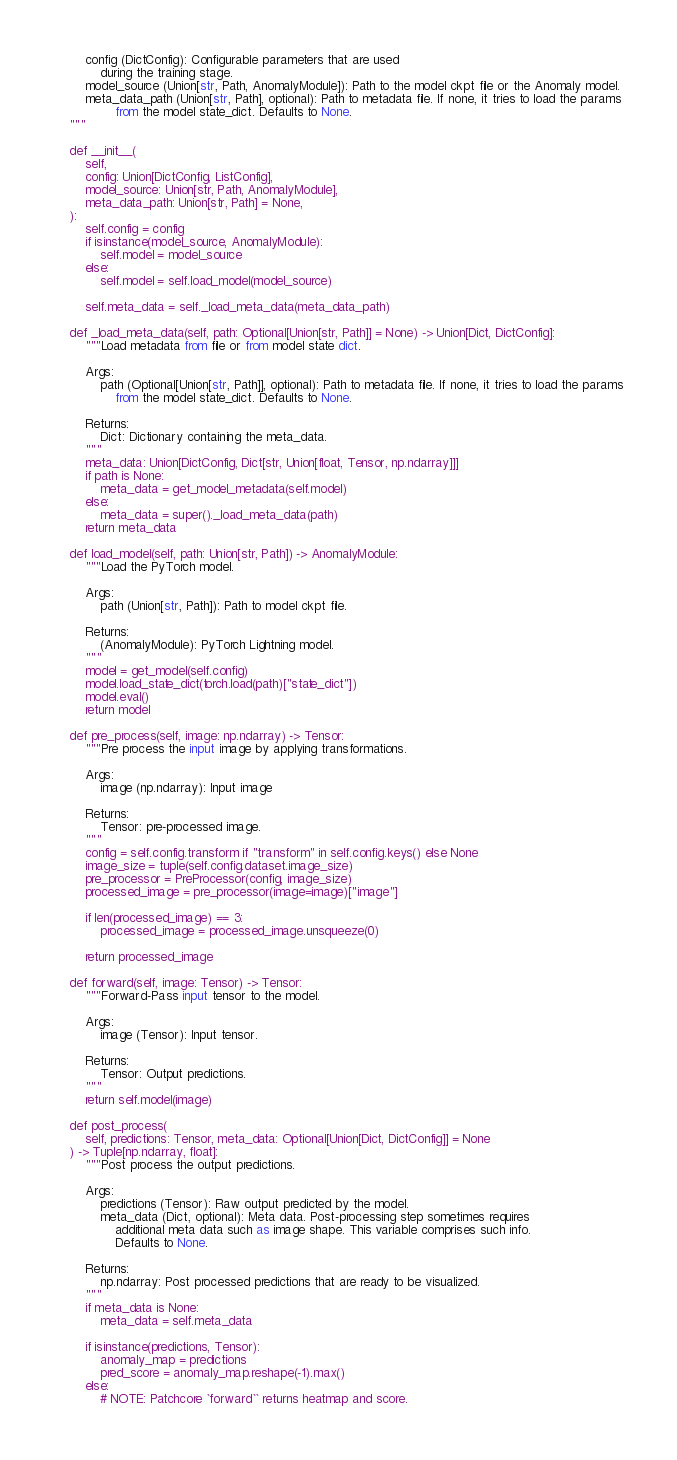Convert code to text. <code><loc_0><loc_0><loc_500><loc_500><_Python_>        config (DictConfig): Configurable parameters that are used
            during the training stage.
        model_source (Union[str, Path, AnomalyModule]): Path to the model ckpt file or the Anomaly model.
        meta_data_path (Union[str, Path], optional): Path to metadata file. If none, it tries to load the params
                from the model state_dict. Defaults to None.
    """

    def __init__(
        self,
        config: Union[DictConfig, ListConfig],
        model_source: Union[str, Path, AnomalyModule],
        meta_data_path: Union[str, Path] = None,
    ):
        self.config = config
        if isinstance(model_source, AnomalyModule):
            self.model = model_source
        else:
            self.model = self.load_model(model_source)

        self.meta_data = self._load_meta_data(meta_data_path)

    def _load_meta_data(self, path: Optional[Union[str, Path]] = None) -> Union[Dict, DictConfig]:
        """Load metadata from file or from model state dict.

        Args:
            path (Optional[Union[str, Path]], optional): Path to metadata file. If none, it tries to load the params
                from the model state_dict. Defaults to None.

        Returns:
            Dict: Dictionary containing the meta_data.
        """
        meta_data: Union[DictConfig, Dict[str, Union[float, Tensor, np.ndarray]]]
        if path is None:
            meta_data = get_model_metadata(self.model)
        else:
            meta_data = super()._load_meta_data(path)
        return meta_data

    def load_model(self, path: Union[str, Path]) -> AnomalyModule:
        """Load the PyTorch model.

        Args:
            path (Union[str, Path]): Path to model ckpt file.

        Returns:
            (AnomalyModule): PyTorch Lightning model.
        """
        model = get_model(self.config)
        model.load_state_dict(torch.load(path)["state_dict"])
        model.eval()
        return model

    def pre_process(self, image: np.ndarray) -> Tensor:
        """Pre process the input image by applying transformations.

        Args:
            image (np.ndarray): Input image

        Returns:
            Tensor: pre-processed image.
        """
        config = self.config.transform if "transform" in self.config.keys() else None
        image_size = tuple(self.config.dataset.image_size)
        pre_processor = PreProcessor(config, image_size)
        processed_image = pre_processor(image=image)["image"]

        if len(processed_image) == 3:
            processed_image = processed_image.unsqueeze(0)

        return processed_image

    def forward(self, image: Tensor) -> Tensor:
        """Forward-Pass input tensor to the model.

        Args:
            image (Tensor): Input tensor.

        Returns:
            Tensor: Output predictions.
        """
        return self.model(image)

    def post_process(
        self, predictions: Tensor, meta_data: Optional[Union[Dict, DictConfig]] = None
    ) -> Tuple[np.ndarray, float]:
        """Post process the output predictions.

        Args:
            predictions (Tensor): Raw output predicted by the model.
            meta_data (Dict, optional): Meta data. Post-processing step sometimes requires
                additional meta data such as image shape. This variable comprises such info.
                Defaults to None.

        Returns:
            np.ndarray: Post processed predictions that are ready to be visualized.
        """
        if meta_data is None:
            meta_data = self.meta_data

        if isinstance(predictions, Tensor):
            anomaly_map = predictions
            pred_score = anomaly_map.reshape(-1).max()
        else:
            # NOTE: Patchcore `forward`` returns heatmap and score.</code> 